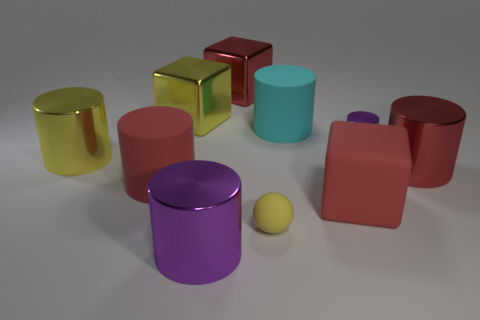Are there any other things that are the same shape as the tiny rubber thing?
Give a very brief answer. No. Is the number of cyan objects behind the tiny yellow rubber thing greater than the number of red objects left of the big red shiny cube?
Your response must be concise. No. The big metallic thing that is right of the large shiny object behind the large yellow metallic block is what color?
Offer a terse response. Red. How many spheres are either small yellow rubber things or large purple metal things?
Give a very brief answer. 1. How many metal objects are both to the right of the small cylinder and behind the yellow shiny cylinder?
Provide a short and direct response. 0. There is a big block that is behind the yellow metal block; what color is it?
Make the answer very short. Red. There is a red cylinder that is made of the same material as the big purple thing; what size is it?
Ensure brevity in your answer.  Large. What number of spheres are behind the red shiny object in front of the big yellow cylinder?
Your answer should be compact. 0. What number of small shiny cylinders are in front of the large yellow cylinder?
Your answer should be very brief. 0. What color is the metallic block in front of the big metallic cube right of the metal cylinder that is in front of the big red matte cylinder?
Your answer should be very brief. Yellow. 